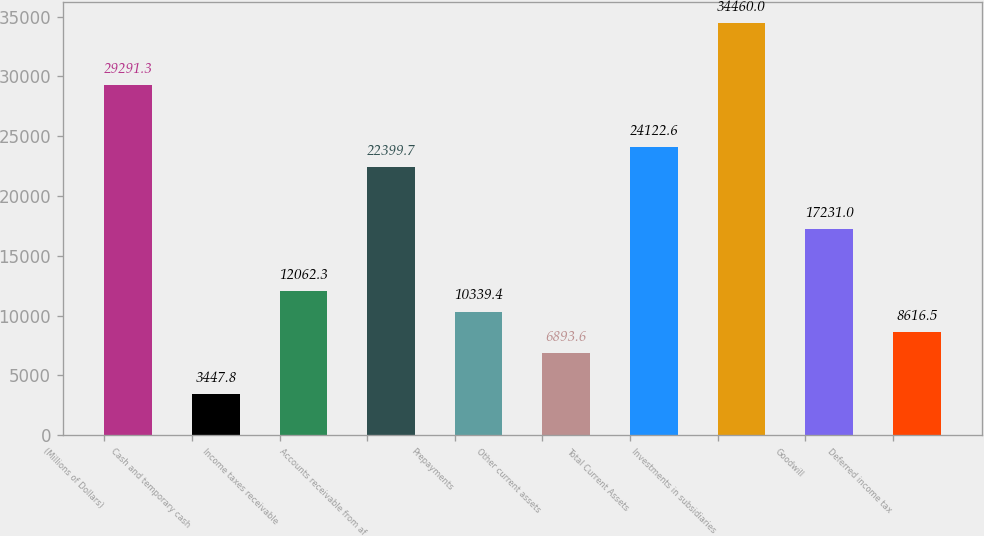<chart> <loc_0><loc_0><loc_500><loc_500><bar_chart><fcel>(Millions of Dollars)<fcel>Cash and temporary cash<fcel>Income taxes receivable<fcel>Accounts receivable from af<fcel>Prepayments<fcel>Other current assets<fcel>Total Current Assets<fcel>Investments in subsidiaries<fcel>Goodwill<fcel>Deferred income tax<nl><fcel>29291.3<fcel>3447.8<fcel>12062.3<fcel>22399.7<fcel>10339.4<fcel>6893.6<fcel>24122.6<fcel>34460<fcel>17231<fcel>8616.5<nl></chart> 